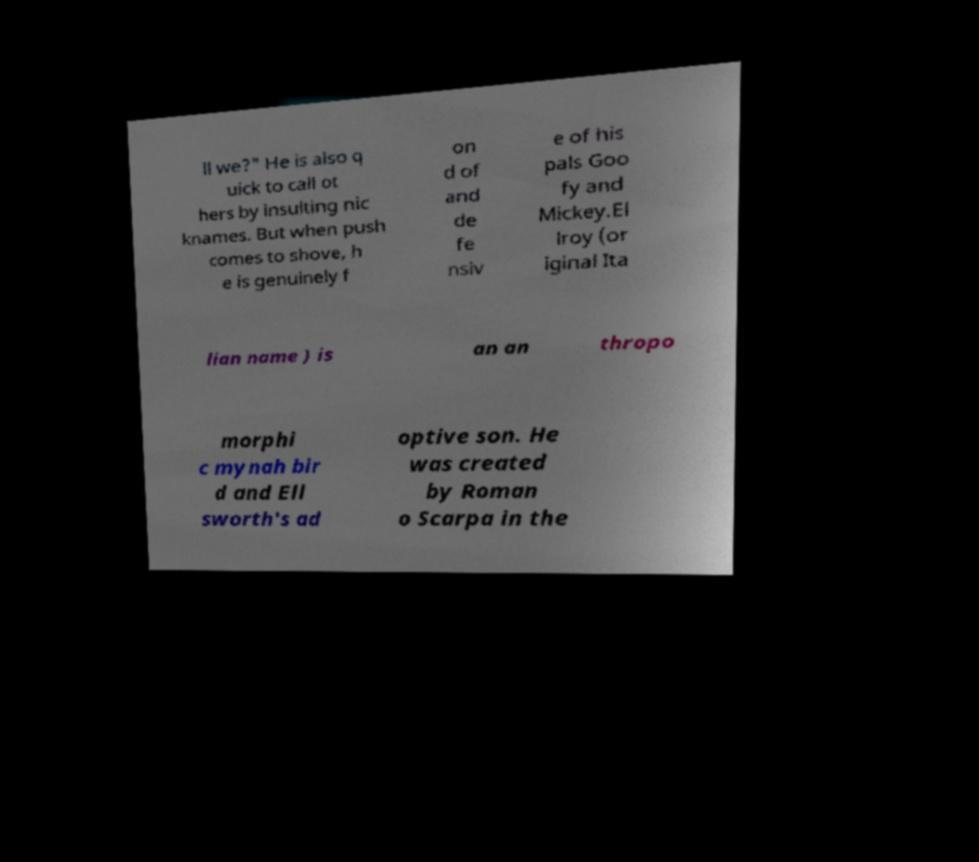Can you accurately transcribe the text from the provided image for me? ll we?" He is also q uick to call ot hers by insulting nic knames. But when push comes to shove, h e is genuinely f on d of and de fe nsiv e of his pals Goo fy and Mickey.El lroy (or iginal Ita lian name ) is an an thropo morphi c mynah bir d and Ell sworth's ad optive son. He was created by Roman o Scarpa in the 